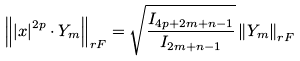<formula> <loc_0><loc_0><loc_500><loc_500>\left \| \left | x \right | ^ { 2 p } \cdot Y _ { m } \right \| _ { r F } = \sqrt { \frac { I _ { 4 p + 2 m + n - 1 } } { I _ { 2 m + n - 1 } } } \left \| Y _ { m } \right \| _ { r F }</formula> 